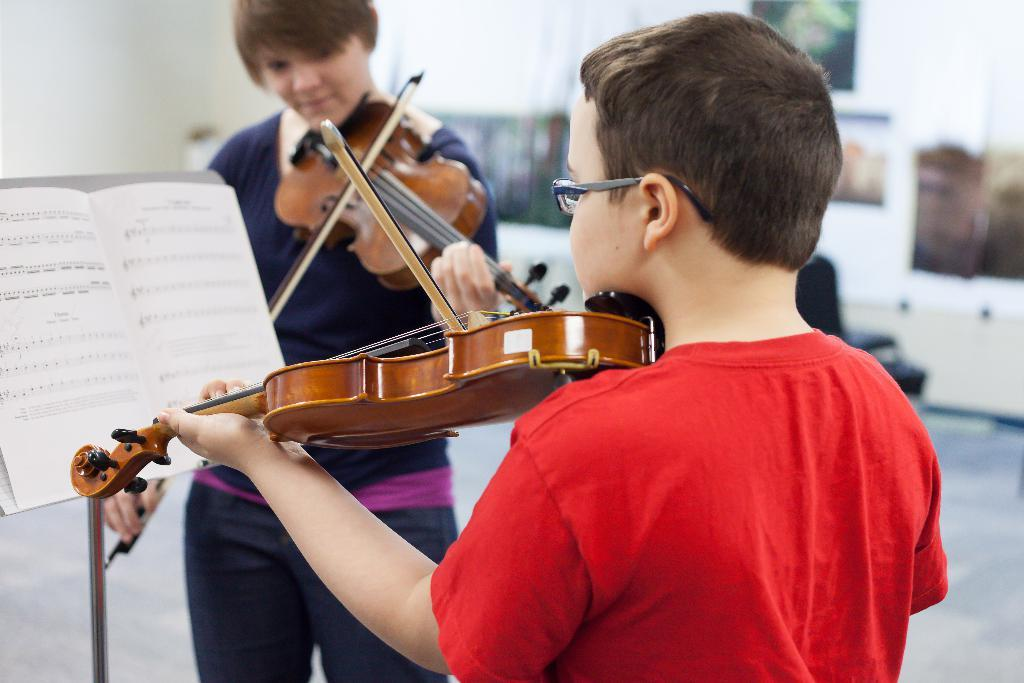What can be seen on the wall in the image? There are photo frames on the wall in the image. What are the two people holding in the image? The two people are holding guitars. Can you identify any other objects in the image? Yes, there is a book visible in the image. Is there a box filled with dirt and a cat in the image? No, there is no box, dirt, or cat present in the image. 